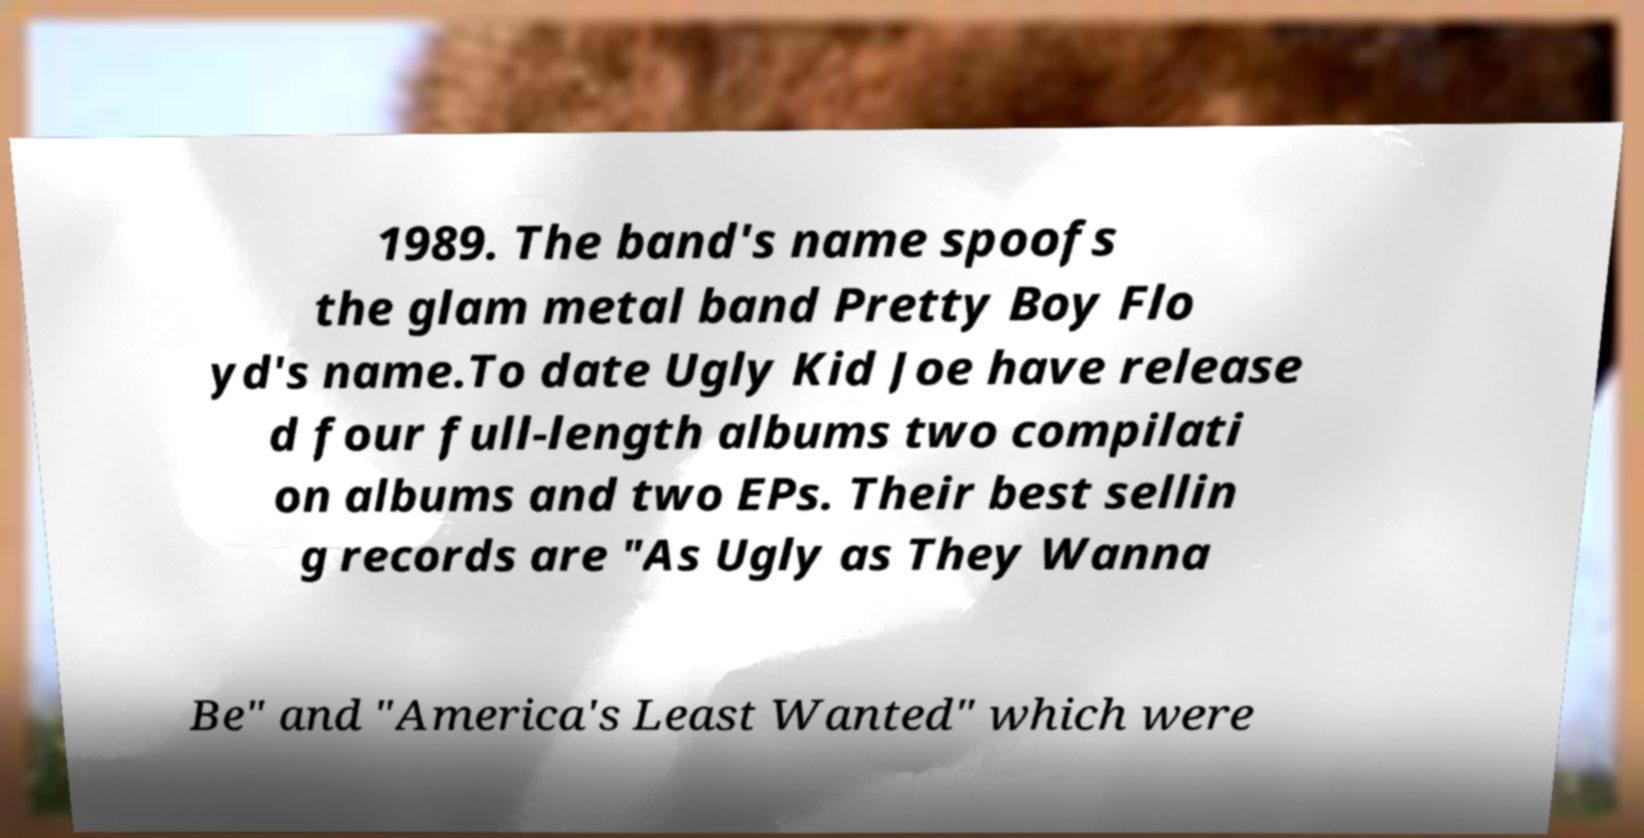There's text embedded in this image that I need extracted. Can you transcribe it verbatim? 1989. The band's name spoofs the glam metal band Pretty Boy Flo yd's name.To date Ugly Kid Joe have release d four full-length albums two compilati on albums and two EPs. Their best sellin g records are "As Ugly as They Wanna Be" and "America's Least Wanted" which were 